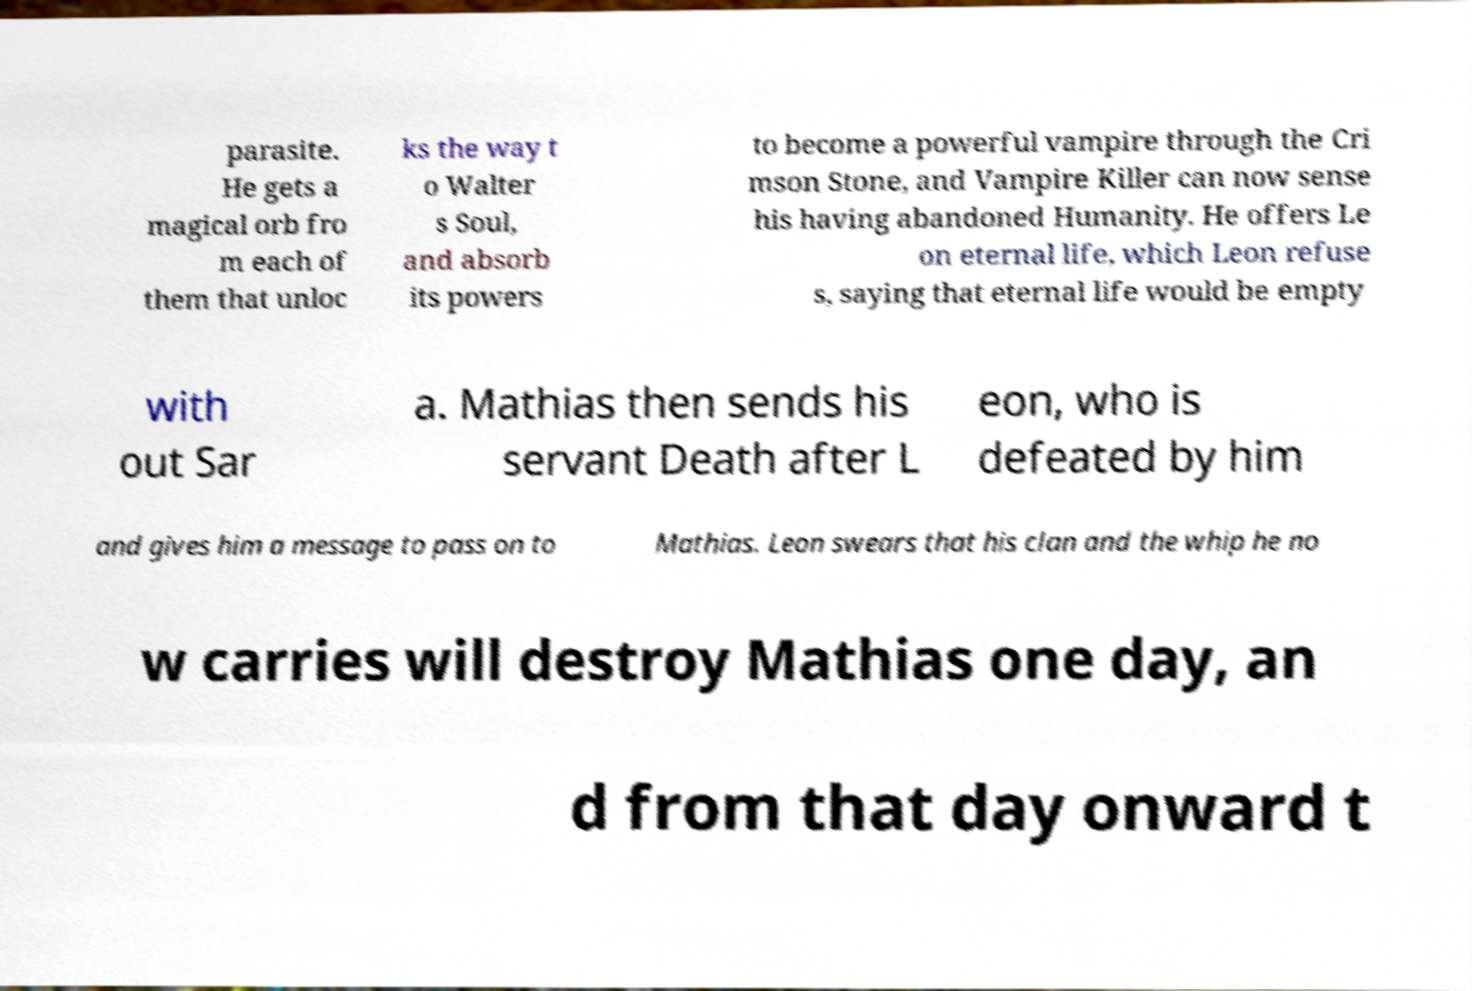Can you read and provide the text displayed in the image?This photo seems to have some interesting text. Can you extract and type it out for me? parasite. He gets a magical orb fro m each of them that unloc ks the way t o Walter s Soul, and absorb its powers to become a powerful vampire through the Cri mson Stone, and Vampire Killer can now sense his having abandoned Humanity. He offers Le on eternal life, which Leon refuse s, saying that eternal life would be empty with out Sar a. Mathias then sends his servant Death after L eon, who is defeated by him and gives him a message to pass on to Mathias. Leon swears that his clan and the whip he no w carries will destroy Mathias one day, an d from that day onward t 